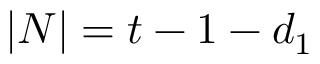Convert formula to latex. <formula><loc_0><loc_0><loc_500><loc_500>| N | = t - 1 - d _ { 1 }</formula> 